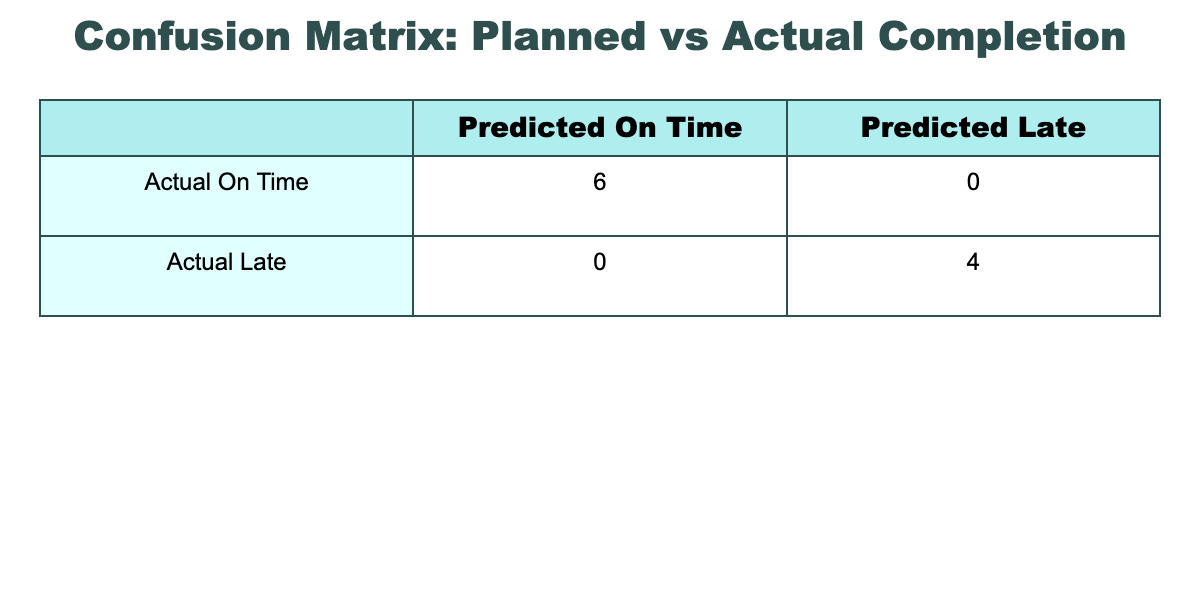What is the total number of productions that were completed on time? From the table, there are 6 instances where the status is "On Time" (the first, third, fifth, seventh, eighth, and tenth rows). Thus, the total count is 6.
Answer: 6 How many productions were completed late? By counting the "Late" statuses in the table, we find there are 4 instances (the second, fourth, sixth, and ninth rows). Therefore, there are 4 late productions.
Answer: 4 What percentage of productions were completed on time? There are 10 total productions. Since 6 were on time, the percentage is (6/10) * 100 = 60%.
Answer: 60% Did any production finish one day early? The first production finished one day early (January 4 instead of January 5). This confirms that at least one was completed early.
Answer: Yes Which production was completed the latest among those that were late? The latest "Late" completion date is July 1 (June's production). Among the late productions, this was the sixth row.
Answer: June 30 What is the average completion time for on-time productions? For the on-time productions (January 4, March 15, May 25, July 5, August 14, September 30), the average is calculated as follows: (1 + 0 + 0 + 0 + -1 + -1) / 6 = -1/6 ≈ -0.167 days late; therefore, on average, they finish slightly early.
Answer: Approximately -0.167 days Is there any instance where the actual completion date was exactly the same as the planned timeline? By checking the table, instances for on-time productions show the actual and planned dates are the same in 6 instances (the first, third, fifth, seventh, eighth, and tenth rows).
Answer: Yes How many instances had a difference of only one day between planned timelines and actual completion dates? There are 5 instances with a one-day difference (the late productions in February, April, June, and September, and the early close in August). This means there are 5 with a one-day difference.
Answer: 5 Was there a pattern in which months had more late productions? The late productions occurred in February, April, June, and September, indicating that these months had a higher count of late completions (4 out of 10 total).
Answer: Yes 